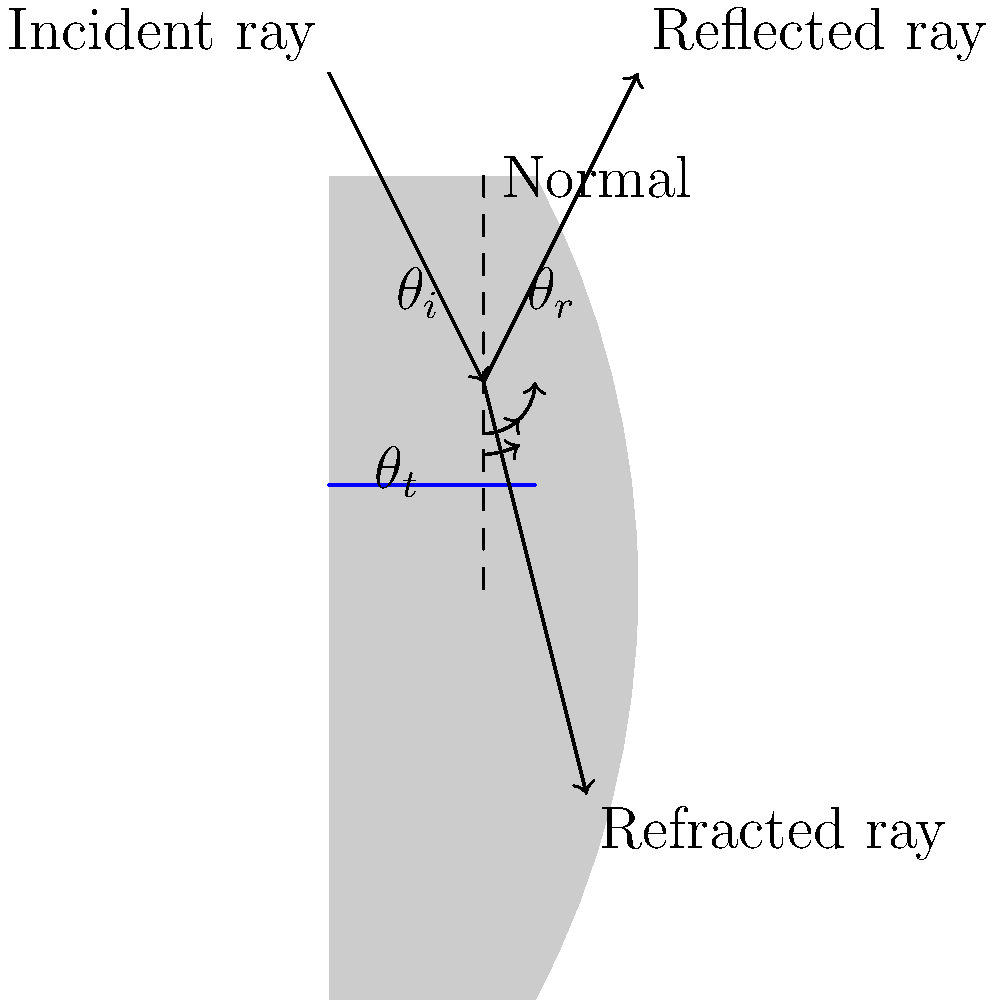In our traditional clay water vessel, we observe the behavior of light as it interacts with water. When light strikes the surface of the water, it both reflects and refracts. If the angle of incidence ($\theta_i$) is 45°, and the refractive index of water is 1.33, what is the angle of refraction ($\theta_t$) of the light as it enters the water? To solve this problem, we'll use Snell's law, which describes the relationship between the angles of incidence and refraction when light passes through different media:

1. Snell's law: $n_1 \sin(\theta_1) = n_2 \sin(\theta_2)$
   Where $n_1$ and $n_2$ are the refractive indices of the two media, and $\theta_1$ and $\theta_2$ are the angles of incidence and refraction, respectively.

2. In our case:
   $n_1 = 1$ (air)
   $n_2 = 1.33$ (water)
   $\theta_1 = \theta_i = 45°$
   $\theta_2 = \theta_t$ (what we're solving for)

3. Substituting these values into Snell's law:
   $1 \cdot \sin(45°) = 1.33 \cdot \sin(\theta_t)$

4. Simplify:
   $\sin(45°) = 1.33 \sin(\theta_t)$

5. We know that $\sin(45°) = \frac{\sqrt{2}}{2} \approx 0.7071$

6. Substituting this value:
   $0.7071 = 1.33 \sin(\theta_t)$

7. Solving for $\sin(\theta_t)$:
   $\sin(\theta_t) = \frac{0.7071}{1.33} \approx 0.5317$

8. To find $\theta_t$, we take the inverse sine (arcsin) of both sides:
   $\theta_t = \arcsin(0.5317) \approx 32.0°$

Therefore, the angle of refraction ($\theta_t$) is approximately 32.0°.
Answer: 32.0° 